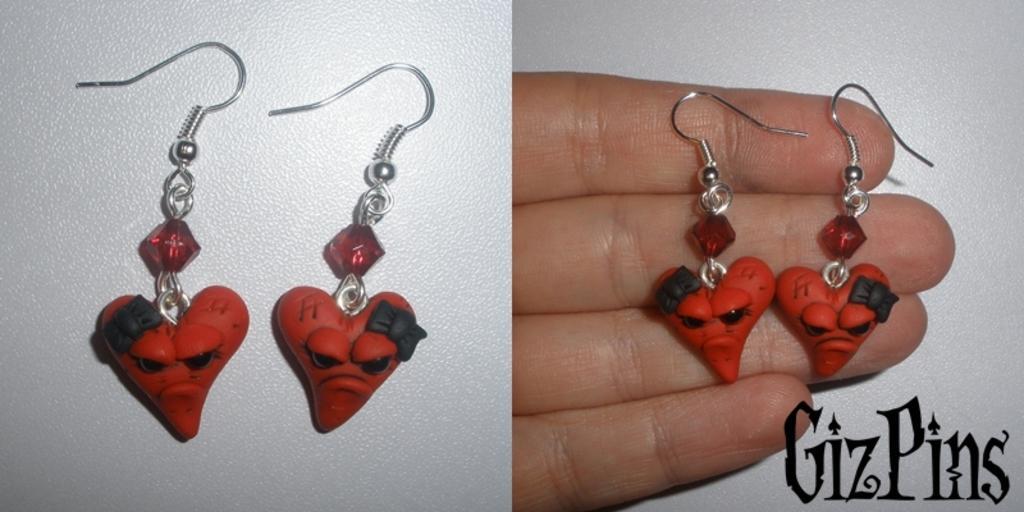In one or two sentences, can you explain what this image depicts? This image is a collage. In this image we can see ear rings placed on the surface. In the second image we can see a person's hand holding ear rings and there is text. 